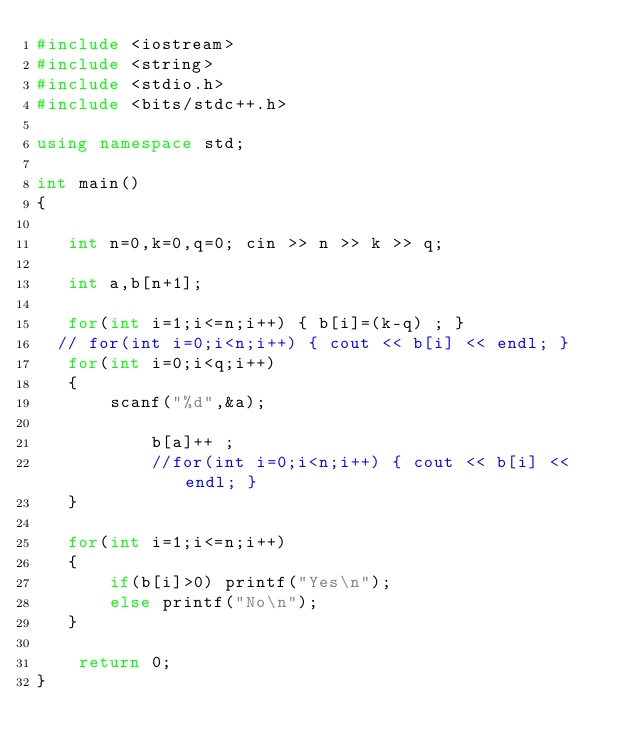Convert code to text. <code><loc_0><loc_0><loc_500><loc_500><_C++_>#include <iostream>
#include <string>
#include <stdio.h>
#include <bits/stdc++.h>

using namespace std;

int main()
{

   int n=0,k=0,q=0; cin >> n >> k >> q;

   int a,b[n+1];

   for(int i=1;i<=n;i++) { b[i]=(k-q) ; }
  // for(int i=0;i<n;i++) { cout << b[i] << endl; }
   for(int i=0;i<q;i++)
   {
       scanf("%d",&a);

           b[a]++ ;
           //for(int i=0;i<n;i++) { cout << b[i] << endl; }
   }

   for(int i=1;i<=n;i++)
   {
       if(b[i]>0) printf("Yes\n");
       else printf("No\n");
   }

    return 0;
}
</code> 